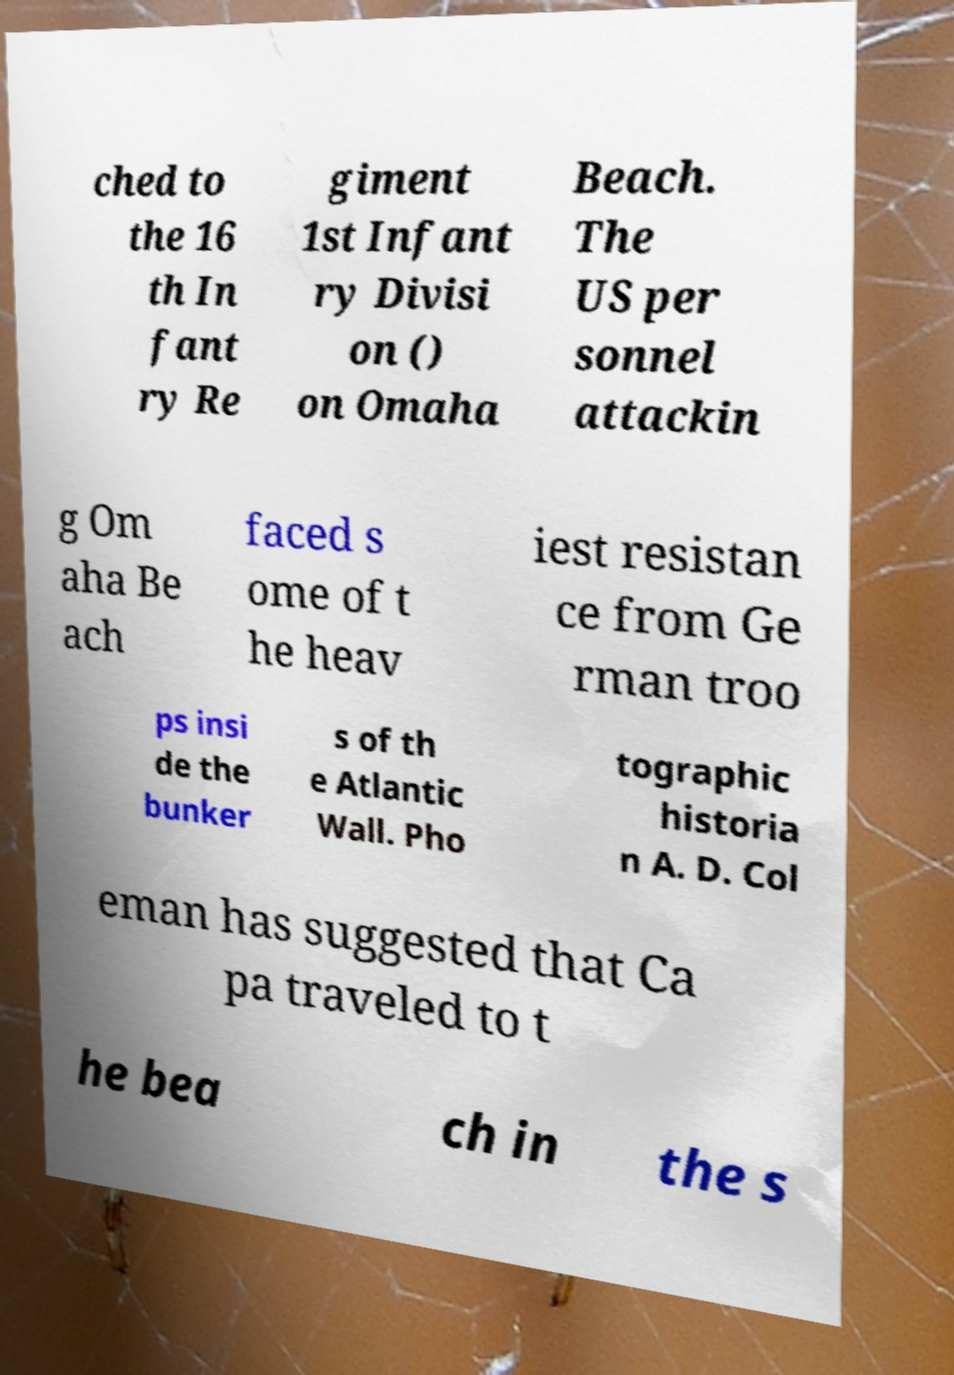I need the written content from this picture converted into text. Can you do that? ched to the 16 th In fant ry Re giment 1st Infant ry Divisi on () on Omaha Beach. The US per sonnel attackin g Om aha Be ach faced s ome of t he heav iest resistan ce from Ge rman troo ps insi de the bunker s of th e Atlantic Wall. Pho tographic historia n A. D. Col eman has suggested that Ca pa traveled to t he bea ch in the s 